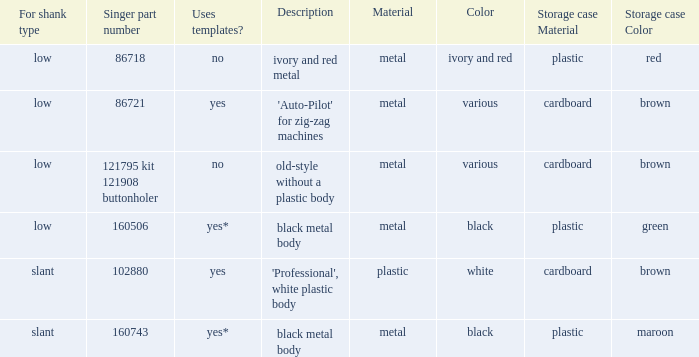What's the singer part number of the buttonholer whose storage case is a green plastic box? 160506.0. 